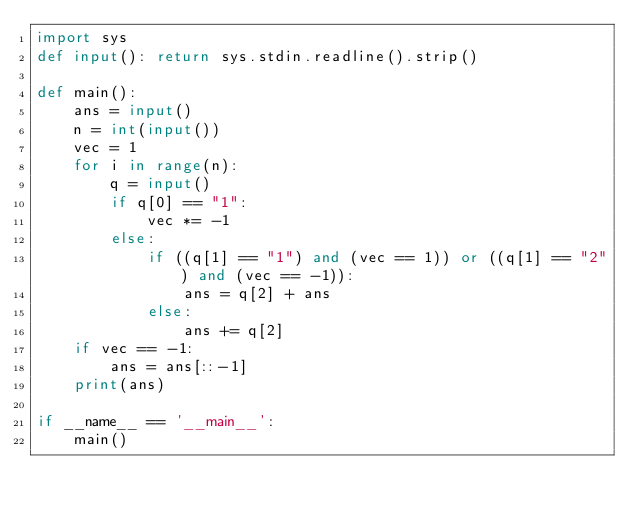Convert code to text. <code><loc_0><loc_0><loc_500><loc_500><_Python_>import sys
def input(): return sys.stdin.readline().strip()

def main():
    ans = input()
    n = int(input())
    vec = 1
    for i in range(n):
        q = input()
        if q[0] == "1":
            vec *= -1
        else:
            if ((q[1] == "1") and (vec == 1)) or ((q[1] == "2") and (vec == -1)):
                ans = q[2] + ans
            else:
                ans += q[2]
    if vec == -1:
        ans = ans[::-1]
    print(ans)

if __name__ == '__main__':
    main()</code> 